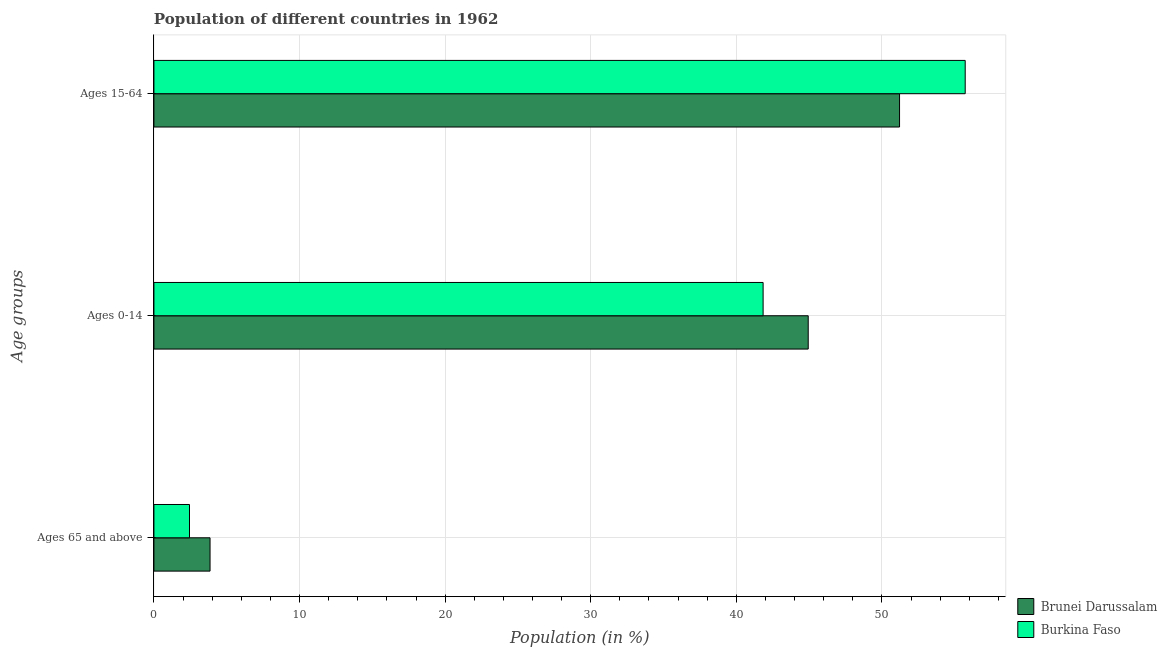How many groups of bars are there?
Your answer should be compact. 3. How many bars are there on the 1st tick from the top?
Provide a succinct answer. 2. How many bars are there on the 3rd tick from the bottom?
Your answer should be very brief. 2. What is the label of the 2nd group of bars from the top?
Offer a terse response. Ages 0-14. What is the percentage of population within the age-group 15-64 in Burkina Faso?
Give a very brief answer. 55.72. Across all countries, what is the maximum percentage of population within the age-group 0-14?
Your response must be concise. 44.94. Across all countries, what is the minimum percentage of population within the age-group 15-64?
Ensure brevity in your answer.  51.21. In which country was the percentage of population within the age-group of 65 and above maximum?
Keep it short and to the point. Brunei Darussalam. In which country was the percentage of population within the age-group of 65 and above minimum?
Provide a short and direct response. Burkina Faso. What is the total percentage of population within the age-group 15-64 in the graph?
Give a very brief answer. 106.93. What is the difference between the percentage of population within the age-group 0-14 in Burkina Faso and that in Brunei Darussalam?
Offer a very short reply. -3.1. What is the difference between the percentage of population within the age-group of 65 and above in Brunei Darussalam and the percentage of population within the age-group 15-64 in Burkina Faso?
Keep it short and to the point. -51.86. What is the average percentage of population within the age-group of 65 and above per country?
Your answer should be very brief. 3.15. What is the difference between the percentage of population within the age-group 15-64 and percentage of population within the age-group 0-14 in Brunei Darussalam?
Offer a terse response. 6.27. What is the ratio of the percentage of population within the age-group 15-64 in Burkina Faso to that in Brunei Darussalam?
Make the answer very short. 1.09. Is the percentage of population within the age-group 15-64 in Burkina Faso less than that in Brunei Darussalam?
Give a very brief answer. No. What is the difference between the highest and the second highest percentage of population within the age-group 15-64?
Make the answer very short. 4.51. What is the difference between the highest and the lowest percentage of population within the age-group 0-14?
Your answer should be very brief. 3.1. In how many countries, is the percentage of population within the age-group 0-14 greater than the average percentage of population within the age-group 0-14 taken over all countries?
Offer a very short reply. 1. Is the sum of the percentage of population within the age-group of 65 and above in Burkina Faso and Brunei Darussalam greater than the maximum percentage of population within the age-group 0-14 across all countries?
Your answer should be compact. No. What does the 1st bar from the top in Ages 65 and above represents?
Offer a terse response. Burkina Faso. What does the 2nd bar from the bottom in Ages 0-14 represents?
Your answer should be very brief. Burkina Faso. How many countries are there in the graph?
Ensure brevity in your answer.  2. What is the difference between two consecutive major ticks on the X-axis?
Provide a short and direct response. 10. Are the values on the major ticks of X-axis written in scientific E-notation?
Offer a terse response. No. Does the graph contain any zero values?
Offer a terse response. No. Does the graph contain grids?
Your answer should be compact. Yes. What is the title of the graph?
Keep it short and to the point. Population of different countries in 1962. What is the label or title of the X-axis?
Your answer should be very brief. Population (in %). What is the label or title of the Y-axis?
Your answer should be compact. Age groups. What is the Population (in %) in Brunei Darussalam in Ages 65 and above?
Your answer should be compact. 3.85. What is the Population (in %) of Burkina Faso in Ages 65 and above?
Your answer should be very brief. 2.44. What is the Population (in %) in Brunei Darussalam in Ages 0-14?
Your answer should be compact. 44.94. What is the Population (in %) of Burkina Faso in Ages 0-14?
Your answer should be compact. 41.84. What is the Population (in %) in Brunei Darussalam in Ages 15-64?
Make the answer very short. 51.21. What is the Population (in %) of Burkina Faso in Ages 15-64?
Your answer should be very brief. 55.72. Across all Age groups, what is the maximum Population (in %) of Brunei Darussalam?
Keep it short and to the point. 51.21. Across all Age groups, what is the maximum Population (in %) in Burkina Faso?
Provide a short and direct response. 55.72. Across all Age groups, what is the minimum Population (in %) of Brunei Darussalam?
Ensure brevity in your answer.  3.85. Across all Age groups, what is the minimum Population (in %) of Burkina Faso?
Give a very brief answer. 2.44. What is the total Population (in %) of Brunei Darussalam in the graph?
Offer a terse response. 100. What is the difference between the Population (in %) of Brunei Darussalam in Ages 65 and above and that in Ages 0-14?
Ensure brevity in your answer.  -41.08. What is the difference between the Population (in %) in Burkina Faso in Ages 65 and above and that in Ages 0-14?
Ensure brevity in your answer.  -39.39. What is the difference between the Population (in %) in Brunei Darussalam in Ages 65 and above and that in Ages 15-64?
Offer a very short reply. -47.35. What is the difference between the Population (in %) in Burkina Faso in Ages 65 and above and that in Ages 15-64?
Offer a very short reply. -53.28. What is the difference between the Population (in %) of Brunei Darussalam in Ages 0-14 and that in Ages 15-64?
Offer a very short reply. -6.27. What is the difference between the Population (in %) in Burkina Faso in Ages 0-14 and that in Ages 15-64?
Provide a succinct answer. -13.88. What is the difference between the Population (in %) in Brunei Darussalam in Ages 65 and above and the Population (in %) in Burkina Faso in Ages 0-14?
Provide a short and direct response. -37.98. What is the difference between the Population (in %) in Brunei Darussalam in Ages 65 and above and the Population (in %) in Burkina Faso in Ages 15-64?
Provide a succinct answer. -51.86. What is the difference between the Population (in %) in Brunei Darussalam in Ages 0-14 and the Population (in %) in Burkina Faso in Ages 15-64?
Offer a very short reply. -10.78. What is the average Population (in %) in Brunei Darussalam per Age groups?
Offer a terse response. 33.33. What is the average Population (in %) of Burkina Faso per Age groups?
Keep it short and to the point. 33.33. What is the difference between the Population (in %) in Brunei Darussalam and Population (in %) in Burkina Faso in Ages 65 and above?
Your answer should be compact. 1.41. What is the difference between the Population (in %) of Brunei Darussalam and Population (in %) of Burkina Faso in Ages 0-14?
Ensure brevity in your answer.  3.1. What is the difference between the Population (in %) in Brunei Darussalam and Population (in %) in Burkina Faso in Ages 15-64?
Offer a very short reply. -4.51. What is the ratio of the Population (in %) of Brunei Darussalam in Ages 65 and above to that in Ages 0-14?
Make the answer very short. 0.09. What is the ratio of the Population (in %) in Burkina Faso in Ages 65 and above to that in Ages 0-14?
Ensure brevity in your answer.  0.06. What is the ratio of the Population (in %) of Brunei Darussalam in Ages 65 and above to that in Ages 15-64?
Provide a short and direct response. 0.08. What is the ratio of the Population (in %) of Burkina Faso in Ages 65 and above to that in Ages 15-64?
Keep it short and to the point. 0.04. What is the ratio of the Population (in %) in Brunei Darussalam in Ages 0-14 to that in Ages 15-64?
Give a very brief answer. 0.88. What is the ratio of the Population (in %) of Burkina Faso in Ages 0-14 to that in Ages 15-64?
Your response must be concise. 0.75. What is the difference between the highest and the second highest Population (in %) in Brunei Darussalam?
Ensure brevity in your answer.  6.27. What is the difference between the highest and the second highest Population (in %) in Burkina Faso?
Your response must be concise. 13.88. What is the difference between the highest and the lowest Population (in %) in Brunei Darussalam?
Provide a succinct answer. 47.35. What is the difference between the highest and the lowest Population (in %) in Burkina Faso?
Make the answer very short. 53.28. 